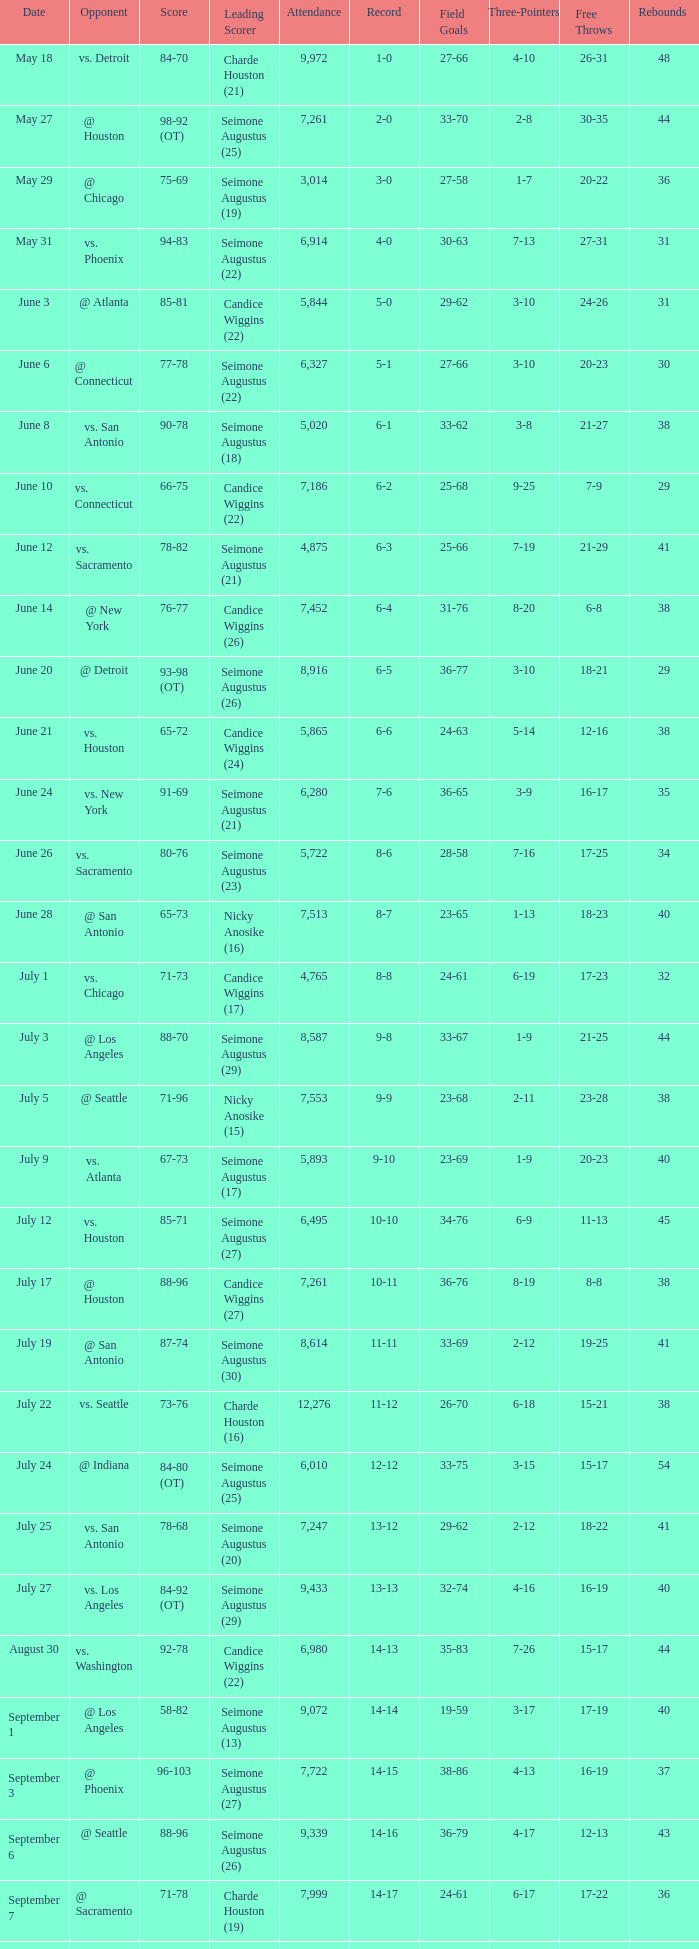Which Score has an Opponent of @ houston, and a Record of 2-0? 98-92 (OT). 